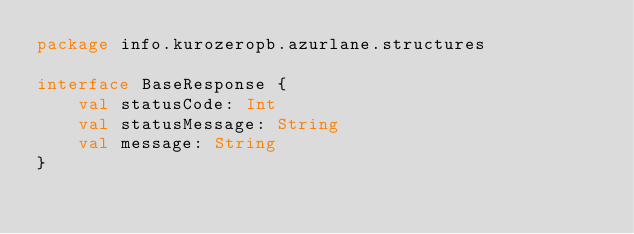<code> <loc_0><loc_0><loc_500><loc_500><_Kotlin_>package info.kurozeropb.azurlane.structures

interface BaseResponse {
    val statusCode: Int
    val statusMessage: String
    val message: String
}</code> 